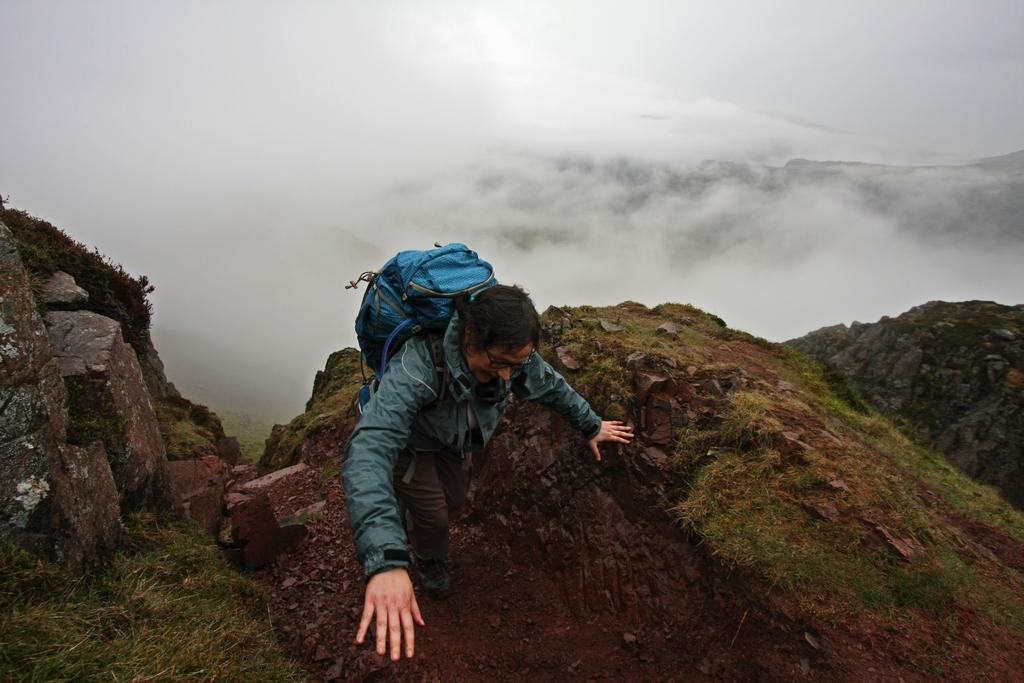What is the main subject of the image? There is a person walking in the center of the image. What can be seen in the background of the image? There is fog in the background of the image. What type of terrain is visible in the front of the image? There is grass on the ground in the front of the image. How many ants can be seen crawling on the person's shoes in the image? There are no ants visible in the image; the focus is on the person walking and the fog in the background. 